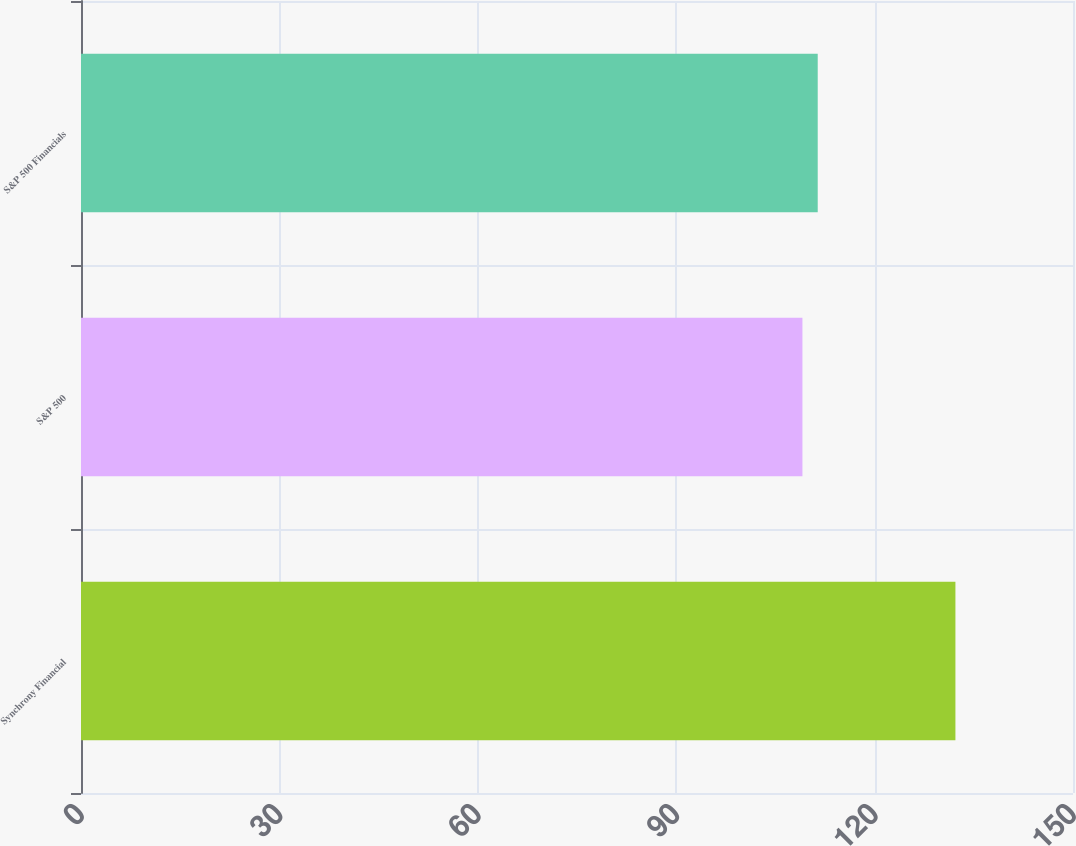<chart> <loc_0><loc_0><loc_500><loc_500><bar_chart><fcel>Synchrony Financial<fcel>S&P 500<fcel>S&P 500 Financials<nl><fcel>132.22<fcel>109.09<fcel>111.4<nl></chart> 